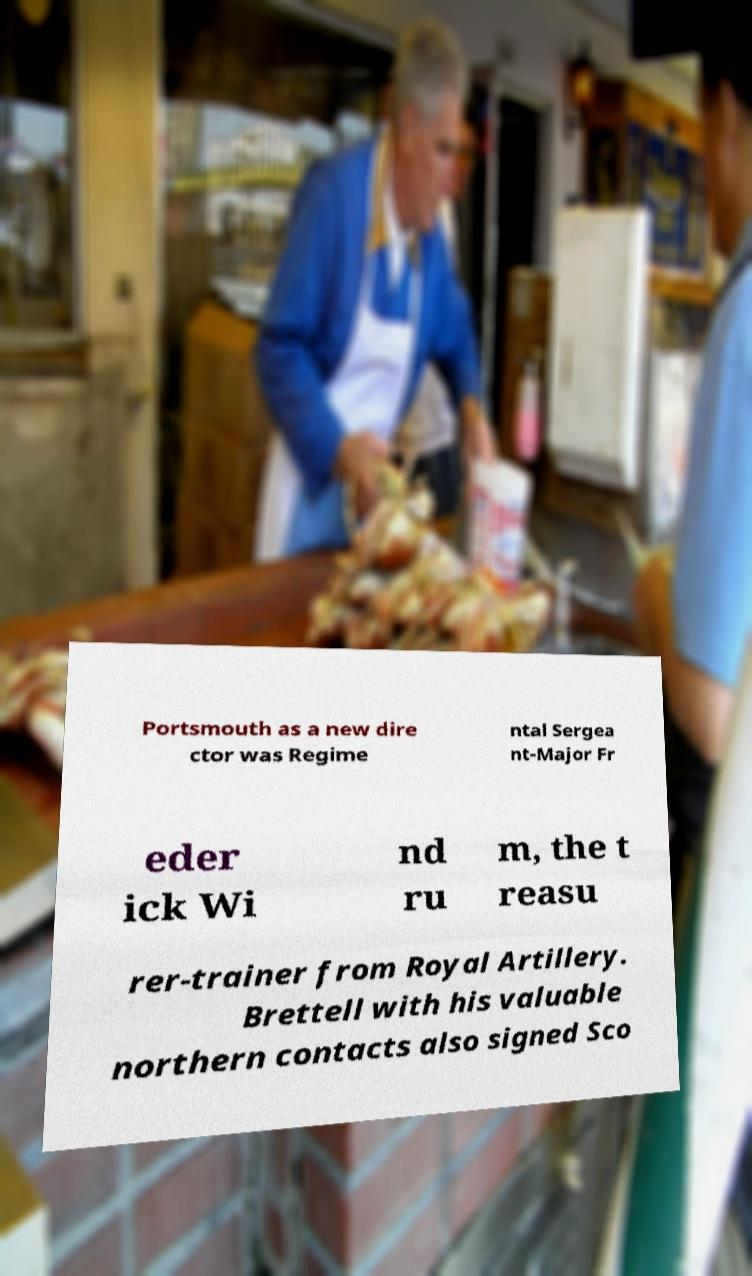I need the written content from this picture converted into text. Can you do that? Portsmouth as a new dire ctor was Regime ntal Sergea nt-Major Fr eder ick Wi nd ru m, the t reasu rer-trainer from Royal Artillery. Brettell with his valuable northern contacts also signed Sco 